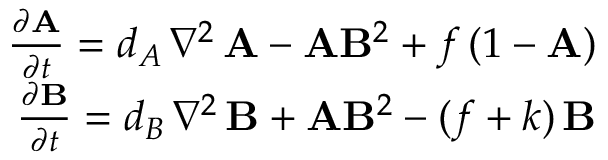<formula> <loc_0><loc_0><loc_500><loc_500>\begin{array} { r } { \frac { \partial A } { \partial t } = d _ { A } \, \nabla ^ { 2 } \, A - A B ^ { 2 } + f \, ( 1 - A ) } \\ { \frac { \partial B } { \partial t } = d _ { B } \, \nabla ^ { 2 } \, B + A B ^ { 2 } - ( f + k ) \, B } \end{array}</formula> 